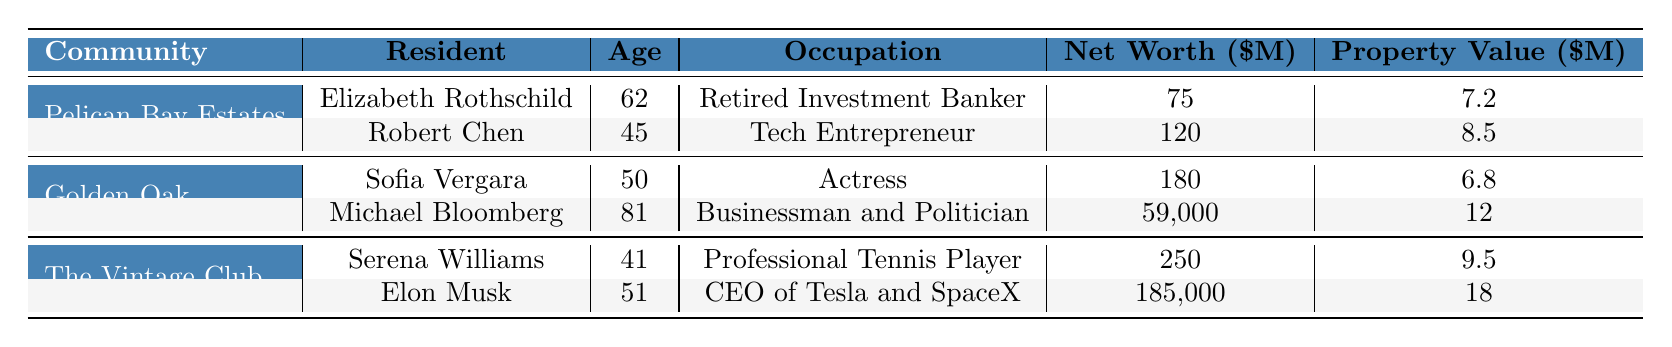What is the average property value in Pelican Bay Estates? The table lists Elizabeth Rothschild's property value as 7.2 million and Robert Chen's as 8.5 million. To find the average, we sum these values (7.2 + 8.5 = 15.7 million) and divide by the number of properties (2), giving us an average of 15.7 / 2 = 7.85 million.
Answer: 7.85 million How many total residents live in The Vintage Club? The table shows that The Vintage Club has 410 total residents listed directly under the community details.
Answer: 410 Is Elon Musk the youngest resident in the table? The ages of residents are: Elizabeth Rothschild (62), Robert Chen (45), Sofia Vergara (50), Michael Bloomberg (81), Serena Williams (41), and Elon Musk (51). The youngest resident is Serena Williams at 41. Therefore, Elon Musk is not the youngest.
Answer: No What is the difference in net worth between Michael Bloomberg and Sofia Vergara? Michael Bloomberg's net worth is 59,000 million and Sofia Vergara's is 180 million. To find the difference, we subtract Sofia's net worth from Bloomberg's: 59,000 - 180 = 58,820 million.
Answer: 58,820 million Which community has the highest average property value? The average property values are 4.5 million for Pelican Bay Estates, 3.8 million for Golden Oak, and 5.2 million for The Vintage Club. Comparing these, The Vintage Club has the highest average of 5.2 million.
Answer: The Vintage Club How many years has Elizabeth Rothschild lived in her community compared to Michael Bloomberg? Elizabeth Rothschild has lived in Pelican Bay Estates for 8 years, while Michael Bloomberg has been in Golden Oak for 2 years. The difference is 8 - 2 = 6 years, meaning Elizabeth has lived there 6 years longer than Michael.
Answer: 6 years What is the total net worth of the residents in Golden Oak? The net worth of residents in Golden Oak are Sofia Vergara (180 million) and Michael Bloomberg (59,000 million). Summing these, 180 + 59,000 = 59,180 million.
Answer: 59,180 million Which community has the lowest amenity score among the three? The amenity scores listed are 9.5 for Pelican Bay Estates, 9.8 for Golden Oak, and 9.7 for The Vintage Club. The lowest score is 9.5 from Pelican Bay Estates.
Answer: Pelican Bay Estates What is the average number of bedrooms for properties in Golden Oak? The properties in Golden Oak have 5 bedrooms (Sofia Vergara) and 8 bedrooms (Michael Bloomberg). To find the average, we sum the bedrooms (5 + 8 = 13) and divide by 2, giving us 13 / 2 = 6.5 bedrooms.
Answer: 6.5 bedrooms How many more total residents does Pelican Bay Estates have compared to Golden Oak? Pelican Bay Estates has 320 residents, while Golden Oak has 280. The difference is 320 - 280 = 40 residents, meaning Pelican Bay Estates has 40 more residents.
Answer: 40 residents Which resident has the highest property value? The property values for the residents are: Elizabeth Rothschild (7.2 million), Robert Chen (8.5 million), Sofia Vergara (6.8 million), Michael Bloomberg (12 million), Serena Williams (9.5 million), and Elon Musk (18 million). The highest value is 18 million from Elon Musk.
Answer: Elon Musk 